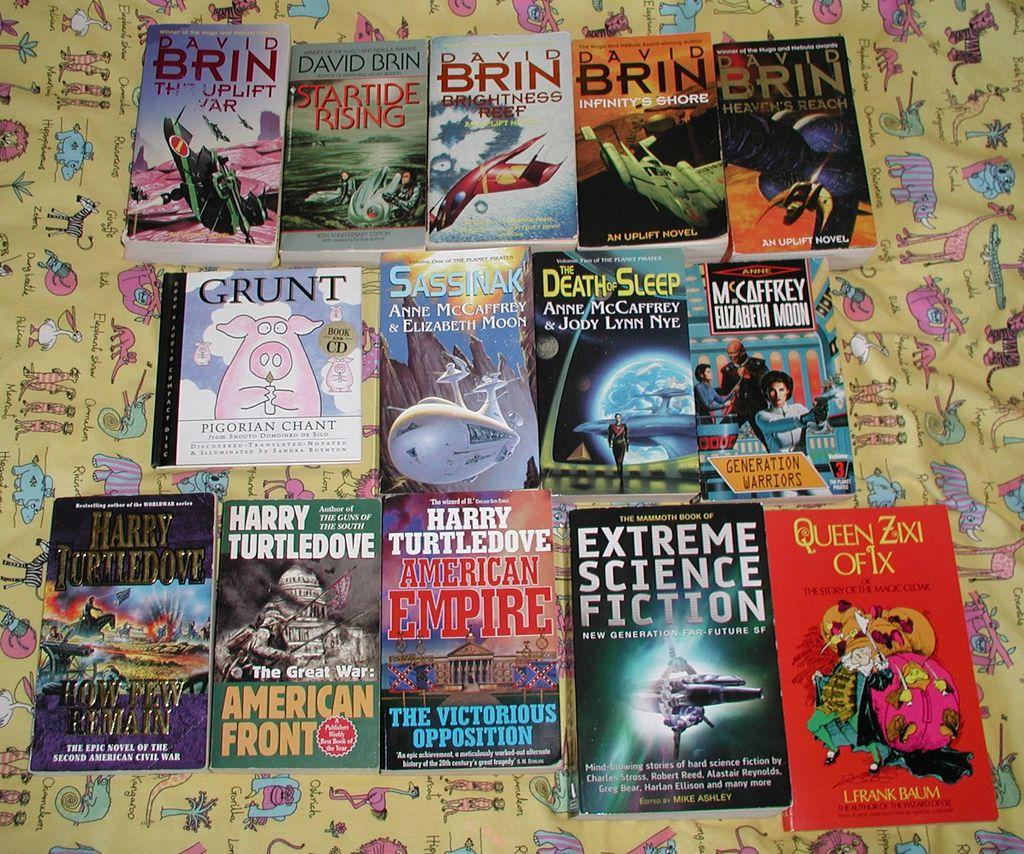Who wrote. "american empire"?
Provide a short and direct response. Harry turtledove. What is the title of the top left book?
Make the answer very short. The uplift war. 